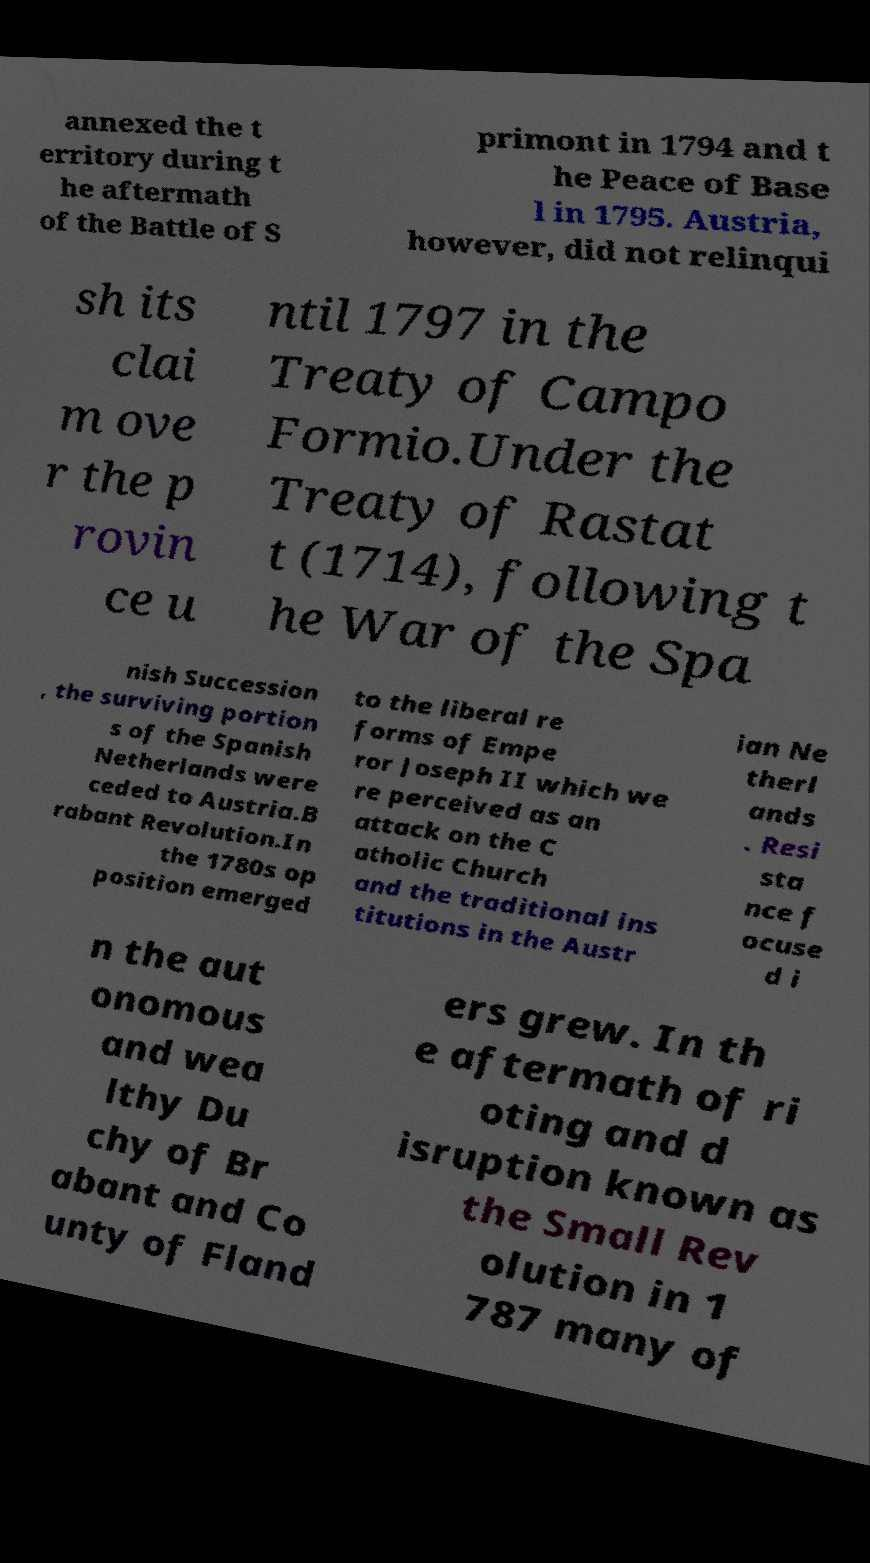Could you assist in decoding the text presented in this image and type it out clearly? annexed the t erritory during t he aftermath of the Battle of S primont in 1794 and t he Peace of Base l in 1795. Austria, however, did not relinqui sh its clai m ove r the p rovin ce u ntil 1797 in the Treaty of Campo Formio.Under the Treaty of Rastat t (1714), following t he War of the Spa nish Succession , the surviving portion s of the Spanish Netherlands were ceded to Austria.B rabant Revolution.In the 1780s op position emerged to the liberal re forms of Empe ror Joseph II which we re perceived as an attack on the C atholic Church and the traditional ins titutions in the Austr ian Ne therl ands . Resi sta nce f ocuse d i n the aut onomous and wea lthy Du chy of Br abant and Co unty of Fland ers grew. In th e aftermath of ri oting and d isruption known as the Small Rev olution in 1 787 many of 